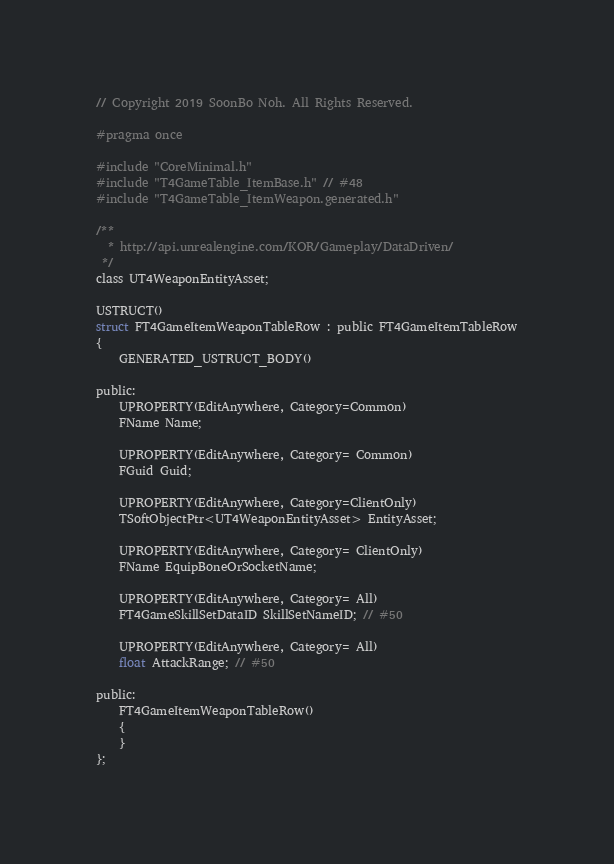<code> <loc_0><loc_0><loc_500><loc_500><_C_>// Copyright 2019 SoonBo Noh. All Rights Reserved.

#pragma once

#include "CoreMinimal.h"
#include "T4GameTable_ItemBase.h" // #48
#include "T4GameTable_ItemWeapon.generated.h"

/**
  * http://api.unrealengine.com/KOR/Gameplay/DataDriven/
 */
class UT4WeaponEntityAsset;

USTRUCT()
struct FT4GameItemWeaponTableRow : public FT4GameItemTableRow
{
	GENERATED_USTRUCT_BODY()

public:
	UPROPERTY(EditAnywhere, Category=Common)
	FName Name;

	UPROPERTY(EditAnywhere, Category= Common)
	FGuid Guid;

	UPROPERTY(EditAnywhere, Category=ClientOnly)
	TSoftObjectPtr<UT4WeaponEntityAsset> EntityAsset;

	UPROPERTY(EditAnywhere, Category= ClientOnly)
	FName EquipBoneOrSocketName;

	UPROPERTY(EditAnywhere, Category= All)
	FT4GameSkillSetDataID SkillSetNameID; // #50

	UPROPERTY(EditAnywhere, Category= All)
	float AttackRange; // #50

public:
	FT4GameItemWeaponTableRow()
	{
	}
};
</code> 